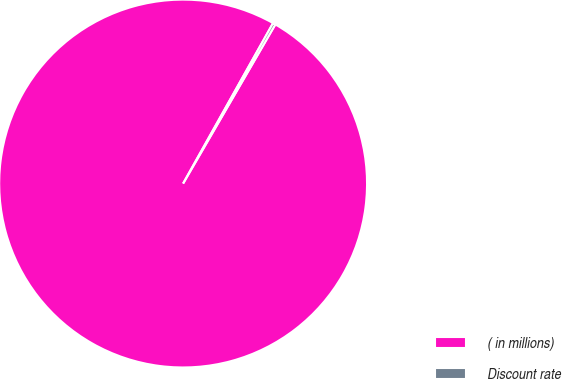<chart> <loc_0><loc_0><loc_500><loc_500><pie_chart><fcel>( in millions)<fcel>Discount rate<nl><fcel>99.77%<fcel>0.23%<nl></chart> 